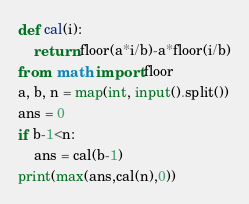<code> <loc_0><loc_0><loc_500><loc_500><_Python_>def cal(i):
    return floor(a*i/b)-a*floor(i/b)
from  math import floor
a, b, n = map(int, input().split())
ans = 0
if b-1<n:
    ans = cal(b-1)
print(max(ans,cal(n),0))</code> 